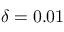Convert formula to latex. <formula><loc_0><loc_0><loc_500><loc_500>\delta = 0 . 0 1</formula> 